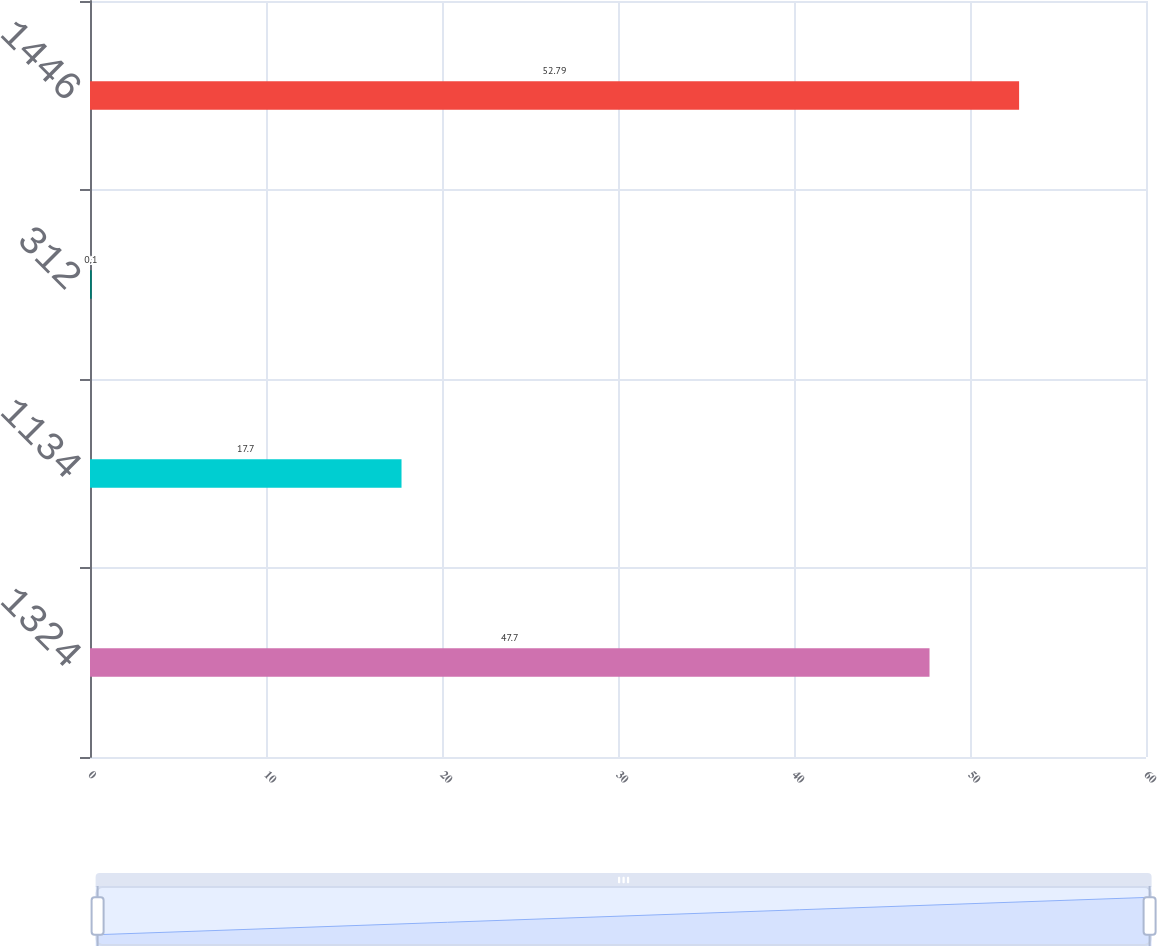<chart> <loc_0><loc_0><loc_500><loc_500><bar_chart><fcel>1324<fcel>1134<fcel>312<fcel>1446<nl><fcel>47.7<fcel>17.7<fcel>0.1<fcel>52.79<nl></chart> 